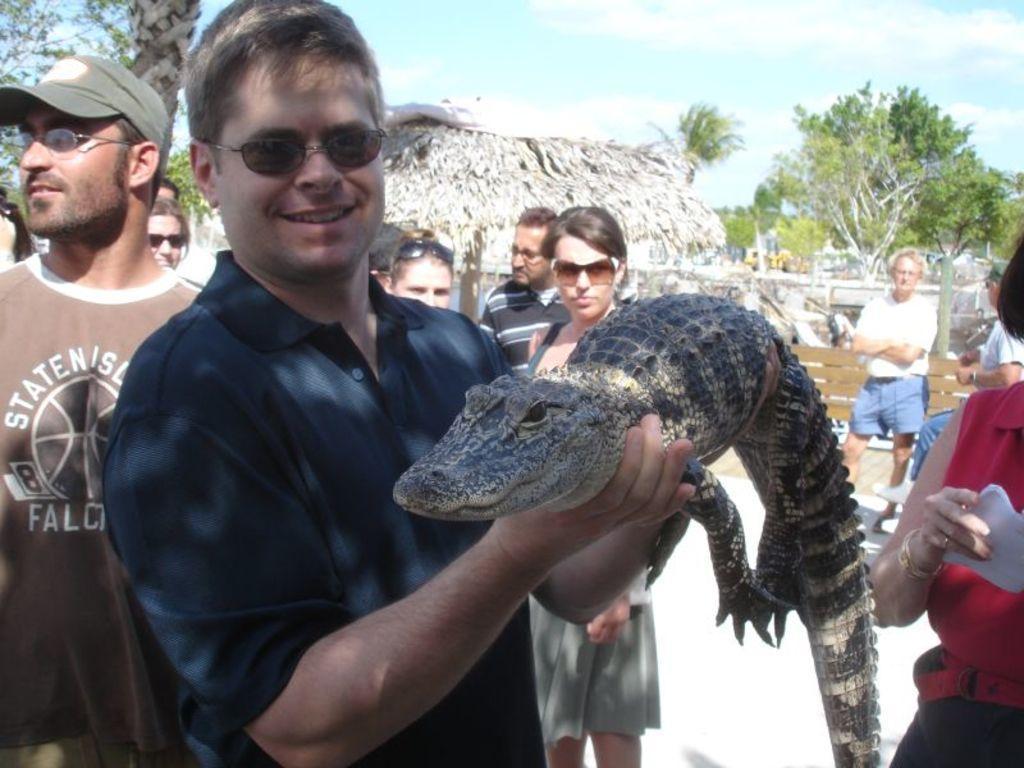Can you describe this image briefly? In this picture we can see a man holding a crocodile with his hands and smiling and at the back of him we can see a group of people wore goggles and standing on the ground, hut, trees and some objects and in the background we can see the sky with clouds. 